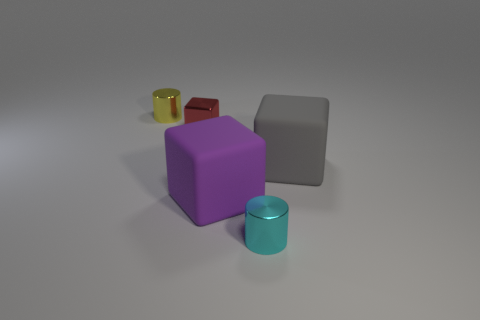Subtract all big cubes. How many cubes are left? 1 Add 2 small yellow metallic cylinders. How many objects exist? 7 Subtract 1 cubes. How many cubes are left? 2 Subtract all cubes. How many objects are left? 2 Subtract all yellow blocks. Subtract all green balls. How many blocks are left? 3 Add 3 tiny cyan metal objects. How many tiny cyan metal objects exist? 4 Subtract 1 yellow cylinders. How many objects are left? 4 Subtract all tiny brown objects. Subtract all tiny yellow things. How many objects are left? 4 Add 1 yellow metal cylinders. How many yellow metal cylinders are left? 2 